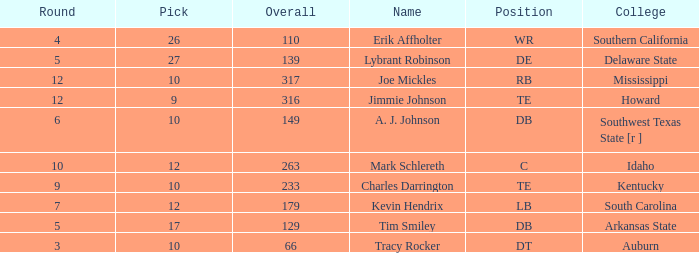What is the sum of Overall, when College is "Arkansas State", and when Pick is less than 17? None. 